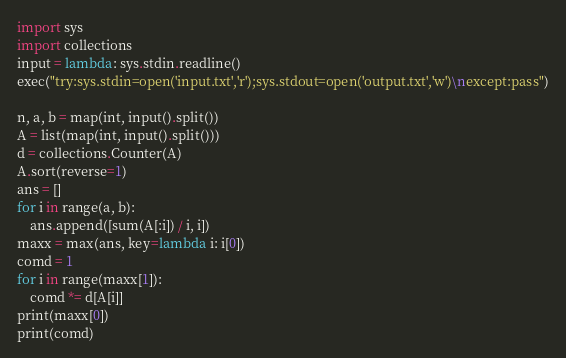<code> <loc_0><loc_0><loc_500><loc_500><_Python_>import sys
import collections
input = lambda: sys.stdin.readline()
exec("try:sys.stdin=open('input.txt','r');sys.stdout=open('output.txt','w')\nexcept:pass")

n, a, b = map(int, input().split())
A = list(map(int, input().split()))
d = collections.Counter(A)
A.sort(reverse=1)
ans = []
for i in range(a, b):
    ans.append([sum(A[:i]) / i, i])
maxx = max(ans, key=lambda i: i[0])
comd = 1
for i in range(maxx[1]):
    comd *= d[A[i]]
print(maxx[0])
print(comd)
</code> 